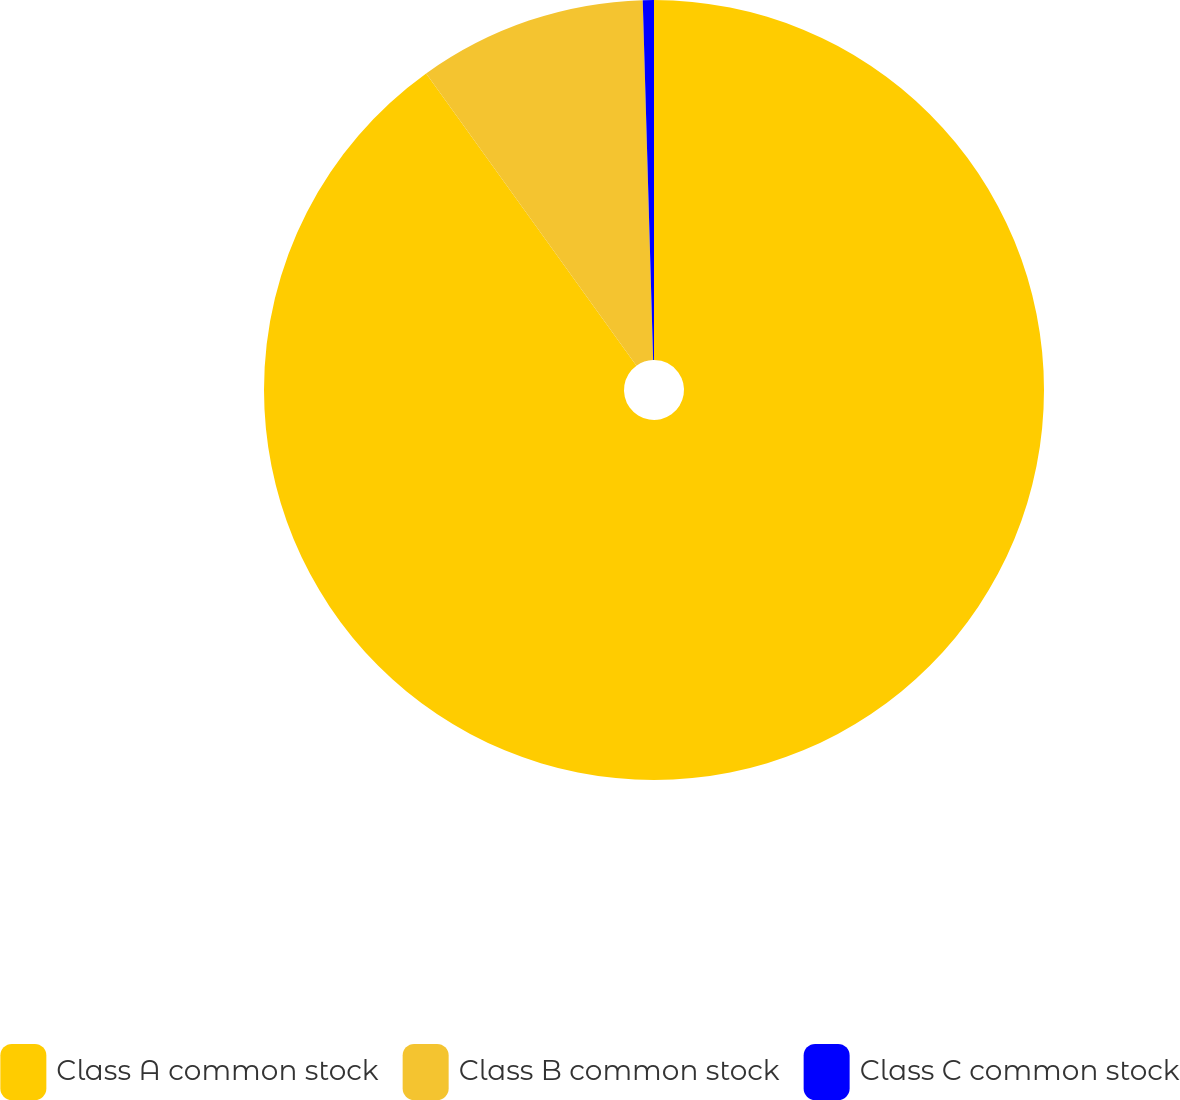Convert chart to OTSL. <chart><loc_0><loc_0><loc_500><loc_500><pie_chart><fcel>Class A common stock<fcel>Class B common stock<fcel>Class C common stock<nl><fcel>90.06%<fcel>9.47%<fcel>0.46%<nl></chart> 